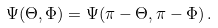Convert formula to latex. <formula><loc_0><loc_0><loc_500><loc_500>\Psi ( \Theta , \Phi ) = \Psi ( \pi - \Theta , \pi - \Phi ) \, .</formula> 